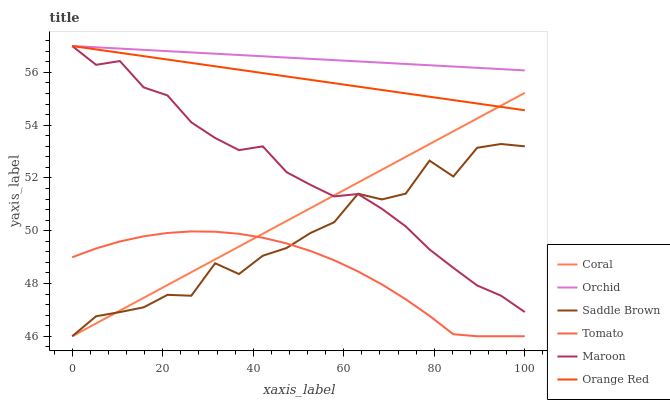Does Tomato have the minimum area under the curve?
Answer yes or no. Yes. Does Orchid have the maximum area under the curve?
Answer yes or no. Yes. Does Coral have the minimum area under the curve?
Answer yes or no. No. Does Coral have the maximum area under the curve?
Answer yes or no. No. Is Orange Red the smoothest?
Answer yes or no. Yes. Is Saddle Brown the roughest?
Answer yes or no. Yes. Is Coral the smoothest?
Answer yes or no. No. Is Coral the roughest?
Answer yes or no. No. Does Maroon have the lowest value?
Answer yes or no. No. Does Orchid have the highest value?
Answer yes or no. Yes. Does Coral have the highest value?
Answer yes or no. No. Is Coral less than Orchid?
Answer yes or no. Yes. Is Orange Red greater than Tomato?
Answer yes or no. Yes. Does Coral intersect Orange Red?
Answer yes or no. Yes. Is Coral less than Orange Red?
Answer yes or no. No. Is Coral greater than Orange Red?
Answer yes or no. No. Does Coral intersect Orchid?
Answer yes or no. No. 